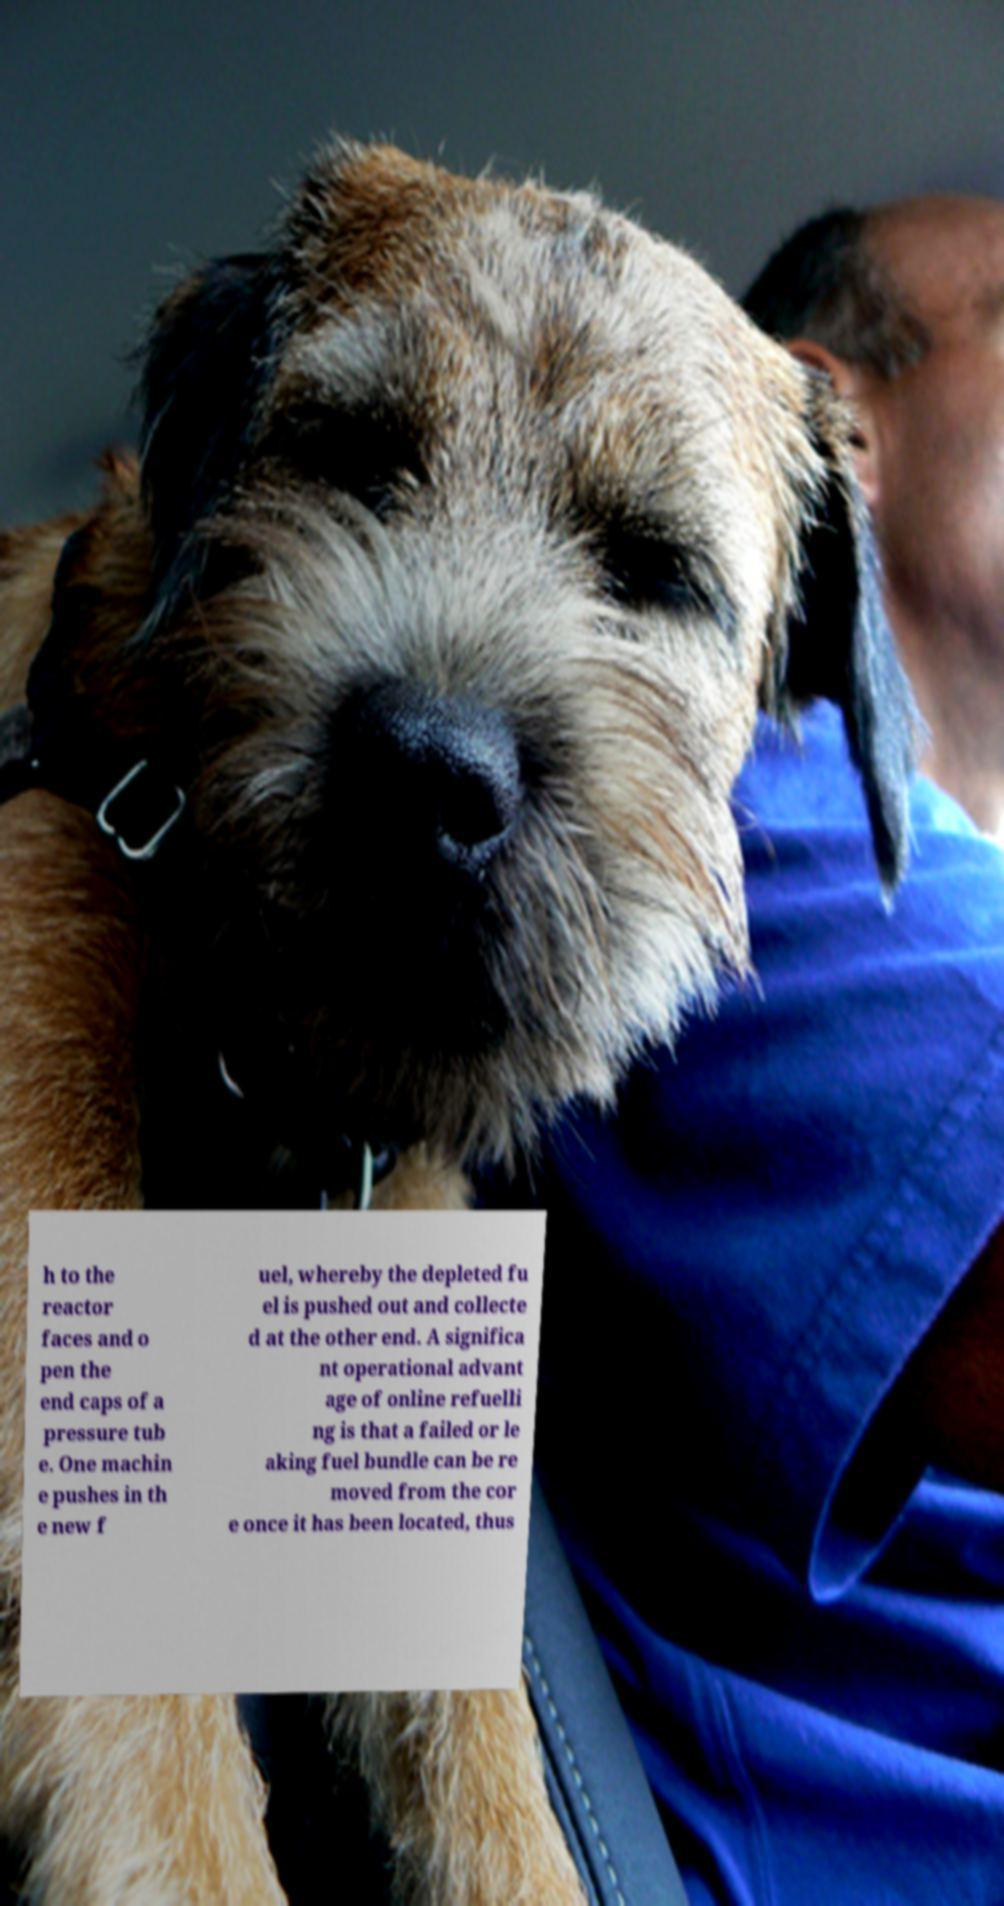Please read and relay the text visible in this image. What does it say? h to the reactor faces and o pen the end caps of a pressure tub e. One machin e pushes in th e new f uel, whereby the depleted fu el is pushed out and collecte d at the other end. A significa nt operational advant age of online refuelli ng is that a failed or le aking fuel bundle can be re moved from the cor e once it has been located, thus 